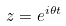Convert formula to latex. <formula><loc_0><loc_0><loc_500><loc_500>z = e ^ { i \theta t }</formula> 